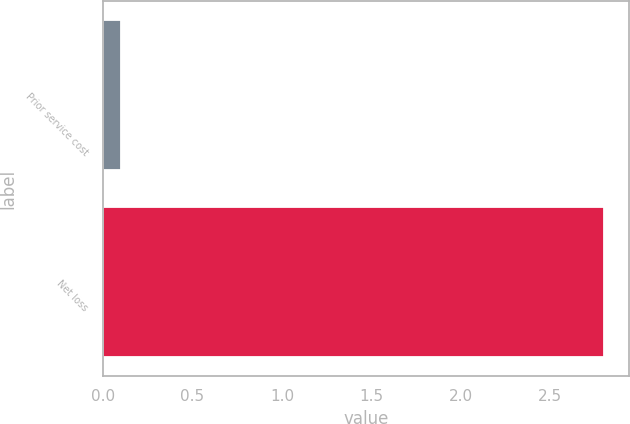Convert chart to OTSL. <chart><loc_0><loc_0><loc_500><loc_500><bar_chart><fcel>Prior service cost<fcel>Net loss<nl><fcel>0.1<fcel>2.8<nl></chart> 